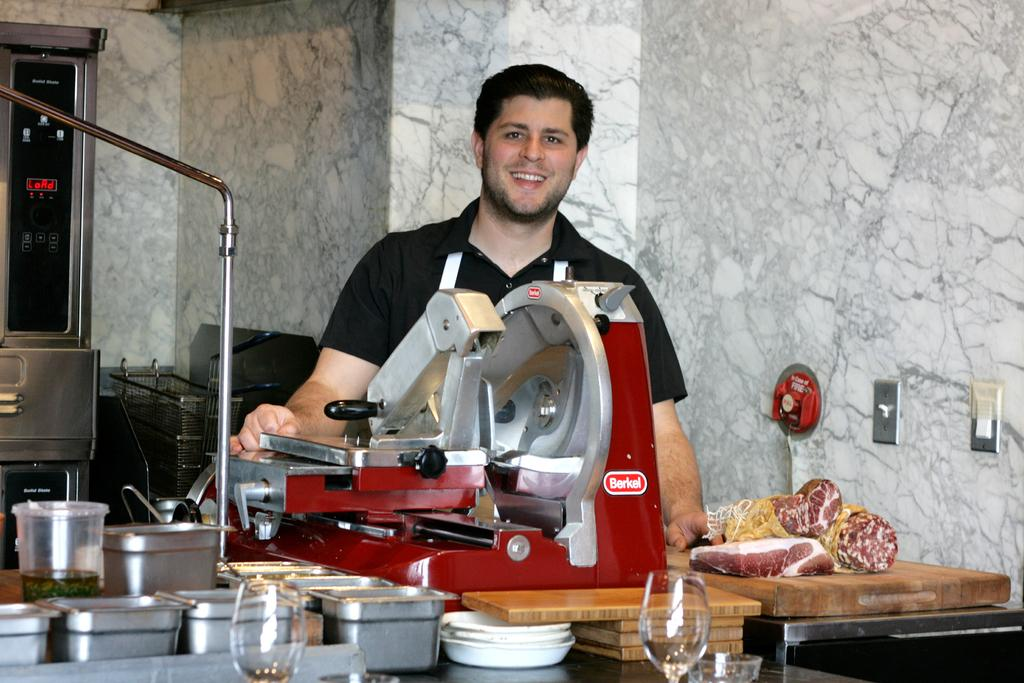<image>
Present a compact description of the photo's key features. The chief only uses Berkel meat slicer, to slice his meat. 